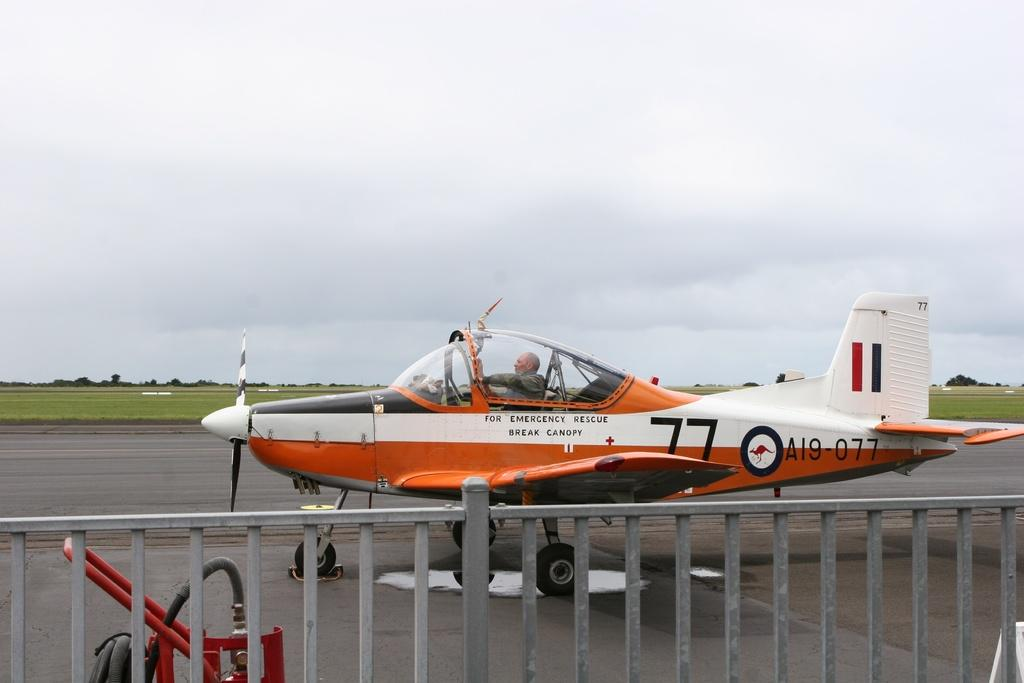<image>
Write a terse but informative summary of the picture. a plane with 77 on the side of it 